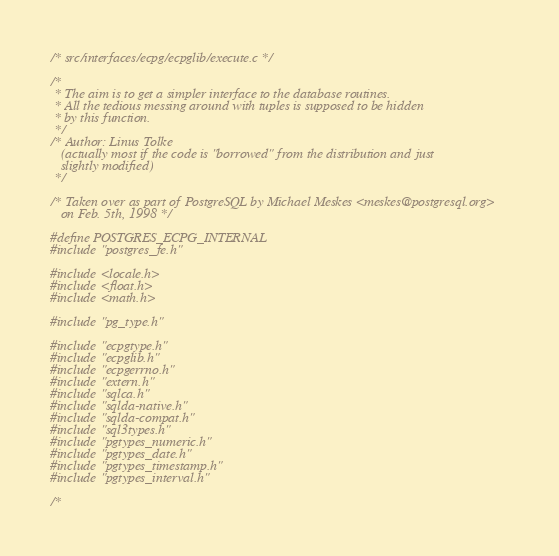<code> <loc_0><loc_0><loc_500><loc_500><_C_>/* src/interfaces/ecpg/ecpglib/execute.c */

/*
 * The aim is to get a simpler interface to the database routines.
 * All the tedious messing around with tuples is supposed to be hidden
 * by this function.
 */
/* Author: Linus Tolke
   (actually most if the code is "borrowed" from the distribution and just
   slightly modified)
 */

/* Taken over as part of PostgreSQL by Michael Meskes <meskes@postgresql.org>
   on Feb. 5th, 1998 */

#define POSTGRES_ECPG_INTERNAL
#include "postgres_fe.h"

#include <locale.h>
#include <float.h>
#include <math.h>

#include "pg_type.h"

#include "ecpgtype.h"
#include "ecpglib.h"
#include "ecpgerrno.h"
#include "extern.h"
#include "sqlca.h"
#include "sqlda-native.h"
#include "sqlda-compat.h"
#include "sql3types.h"
#include "pgtypes_numeric.h"
#include "pgtypes_date.h"
#include "pgtypes_timestamp.h"
#include "pgtypes_interval.h"

/*</code> 